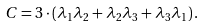Convert formula to latex. <formula><loc_0><loc_0><loc_500><loc_500>C = 3 \cdot ( \lambda _ { 1 } \lambda _ { 2 } + \lambda _ { 2 } \lambda _ { 3 } + \lambda _ { 3 } \lambda _ { 1 } ) \, .</formula> 